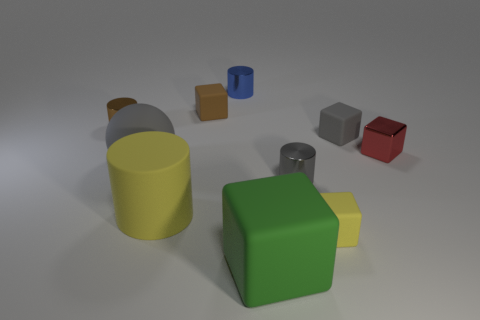How many gray matte balls have the same size as the brown metallic object?
Your answer should be compact. 0. Are there more yellow things in front of the yellow cylinder than small gray matte objects that are in front of the big green object?
Offer a terse response. Yes. Is there a cyan matte thing that has the same shape as the large green matte thing?
Provide a short and direct response. No. There is a brown object on the left side of the gray rubber object that is to the left of the large rubber cube; how big is it?
Make the answer very short. Small. The tiny shiny thing behind the small object to the left of the tiny rubber object that is behind the small gray cube is what shape?
Give a very brief answer. Cylinder. What size is the block that is the same material as the gray cylinder?
Provide a succinct answer. Small. Is the number of tiny purple cylinders greater than the number of brown cylinders?
Your response must be concise. No. What is the material of the cylinder that is the same size as the green block?
Your answer should be compact. Rubber. There is a metallic cylinder to the left of the ball; does it have the same size as the large gray matte thing?
Offer a very short reply. No. How many cubes are either small gray objects or gray shiny objects?
Your answer should be compact. 1. 